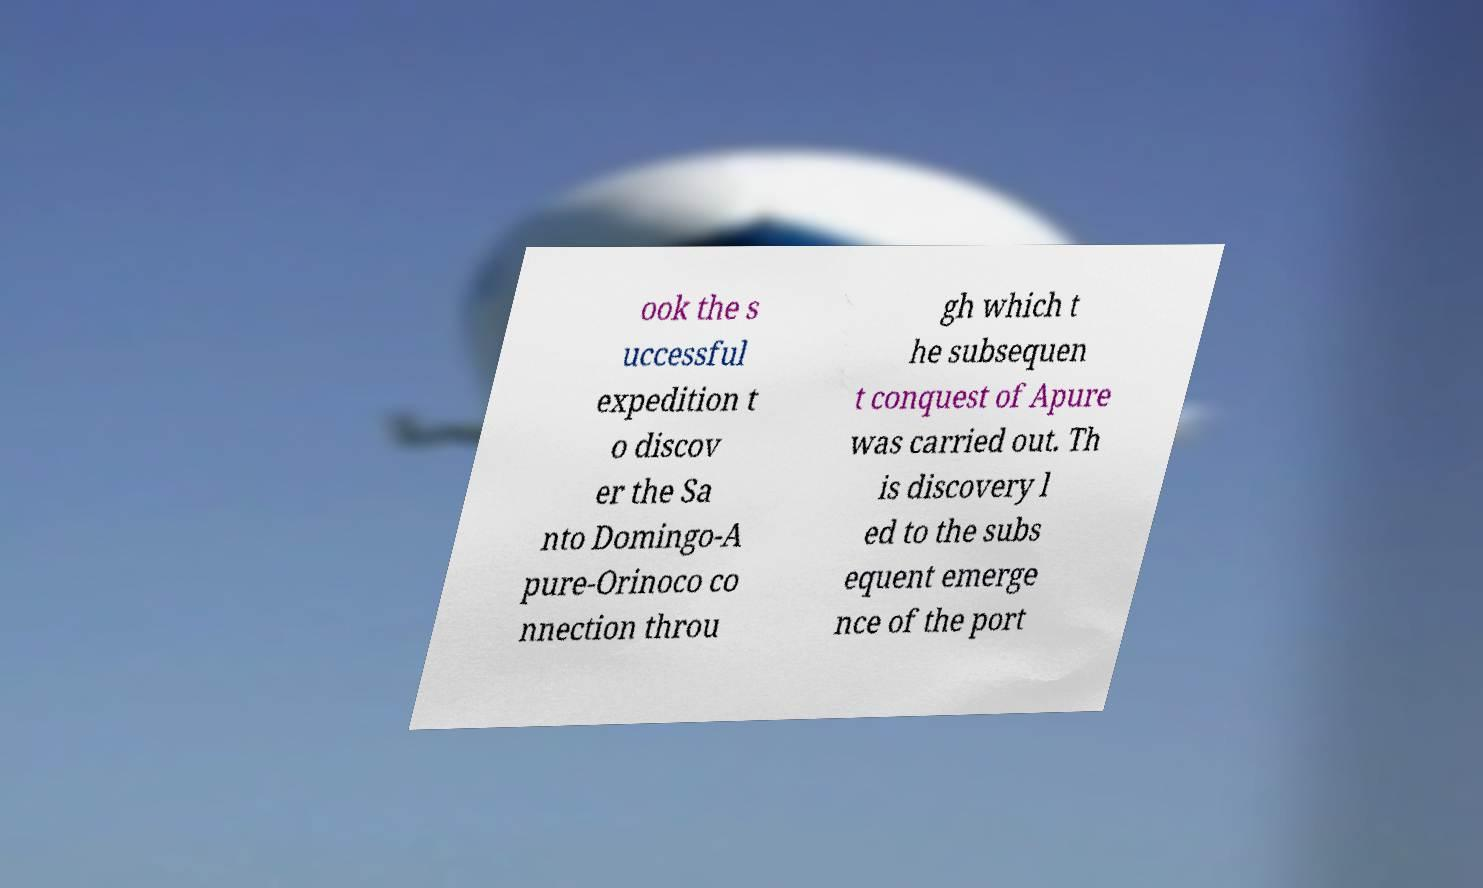I need the written content from this picture converted into text. Can you do that? ook the s uccessful expedition t o discov er the Sa nto Domingo-A pure-Orinoco co nnection throu gh which t he subsequen t conquest of Apure was carried out. Th is discovery l ed to the subs equent emerge nce of the port 